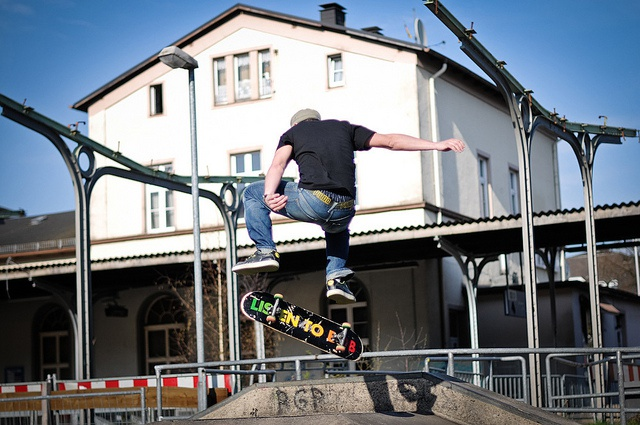Describe the objects in this image and their specific colors. I can see people in gray, black, and lightgray tones and skateboard in gray, black, darkgray, and ivory tones in this image. 